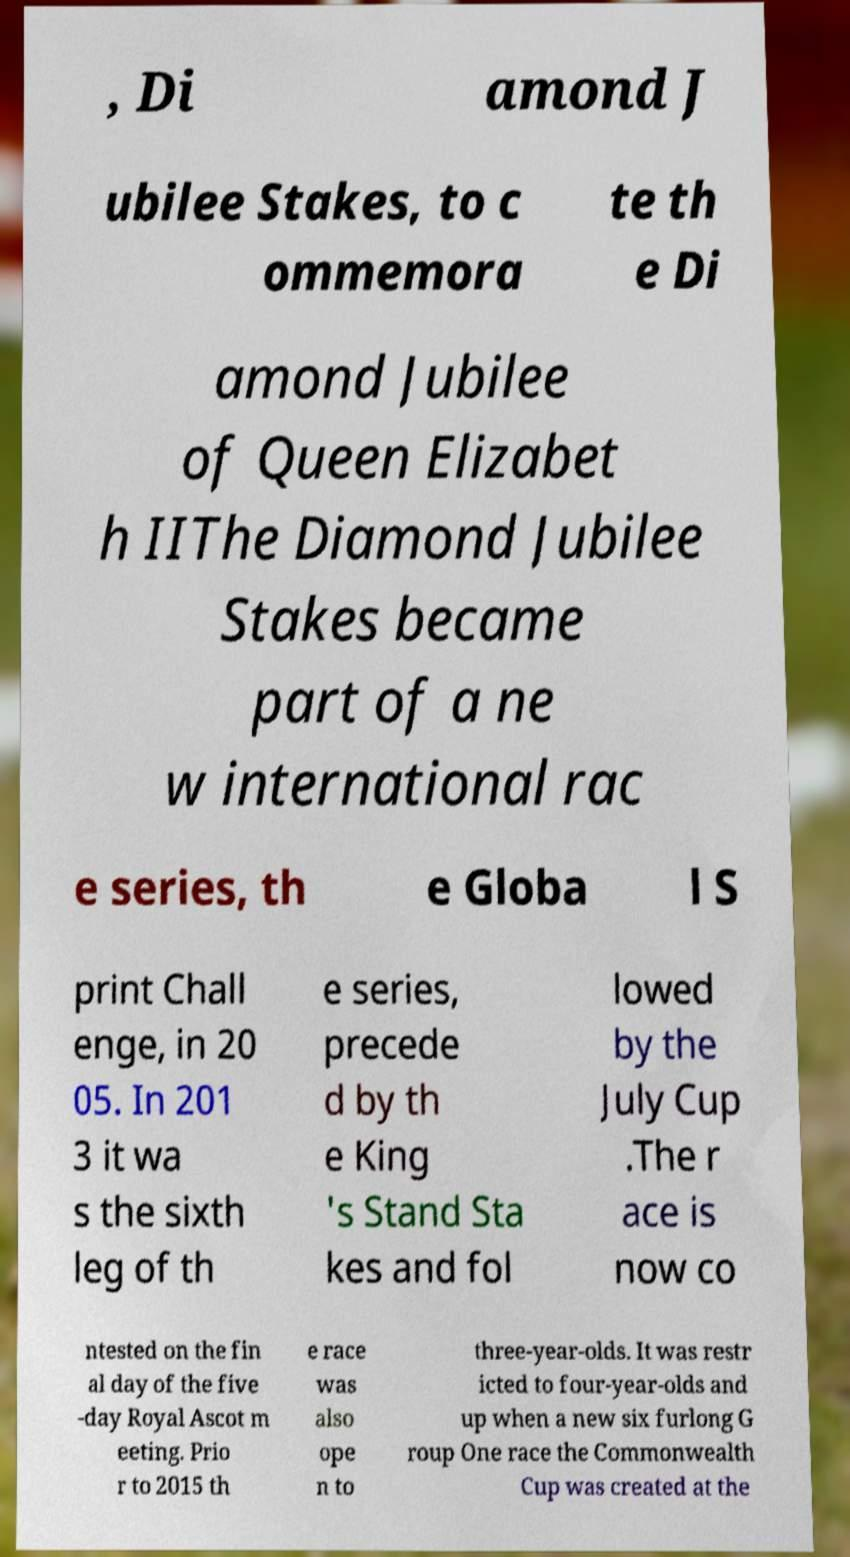Could you assist in decoding the text presented in this image and type it out clearly? , Di amond J ubilee Stakes, to c ommemora te th e Di amond Jubilee of Queen Elizabet h IIThe Diamond Jubilee Stakes became part of a ne w international rac e series, th e Globa l S print Chall enge, in 20 05. In 201 3 it wa s the sixth leg of th e series, precede d by th e King 's Stand Sta kes and fol lowed by the July Cup .The r ace is now co ntested on the fin al day of the five -day Royal Ascot m eeting. Prio r to 2015 th e race was also ope n to three-year-olds. It was restr icted to four-year-olds and up when a new six furlong G roup One race the Commonwealth Cup was created at the 